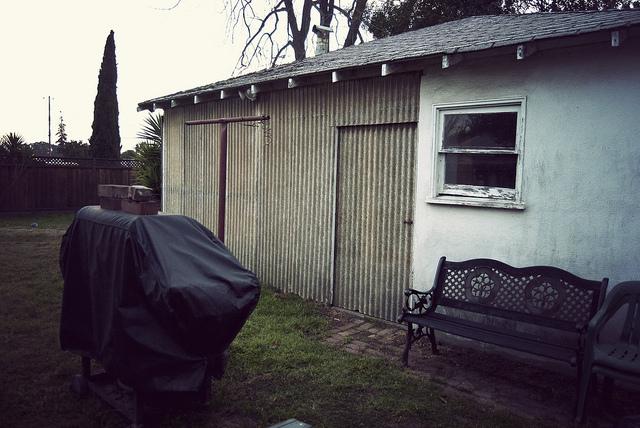Do you see a grill?
Be succinct. Yes. Do wealthy people likely live here?
Keep it brief. No. Is there a chair pictured?
Quick response, please. Yes. What color is the doors?
Quick response, please. Brown. 